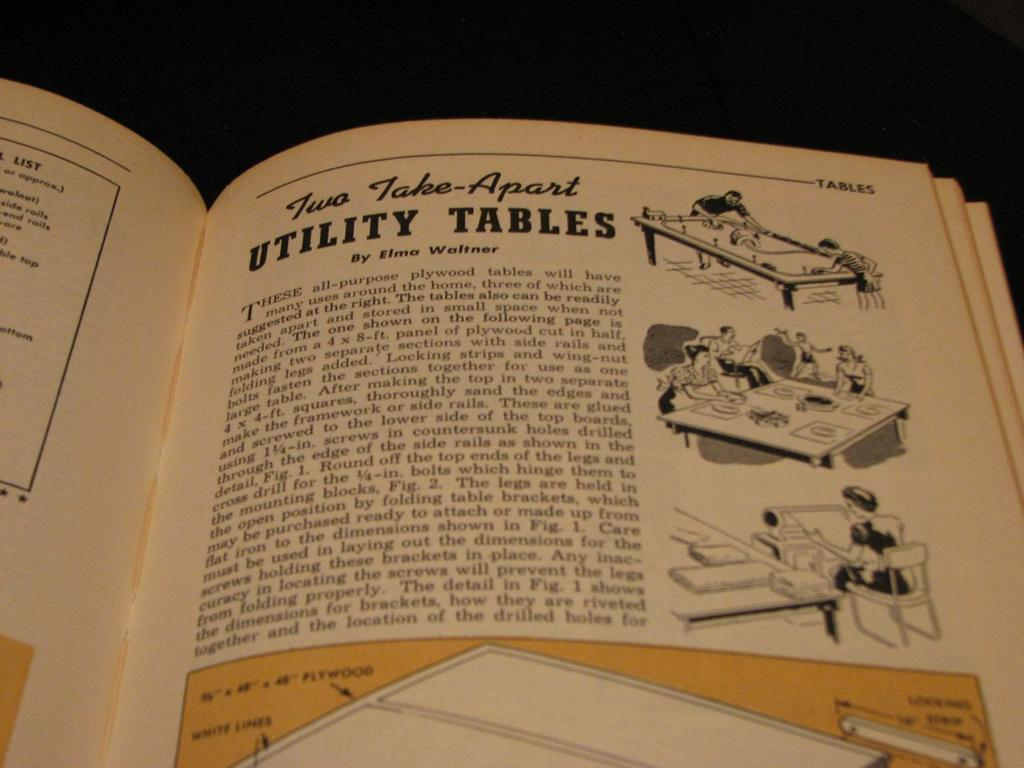<image>
Render a clear and concise summary of the photo. A book is open to a page with information about utility tables. 